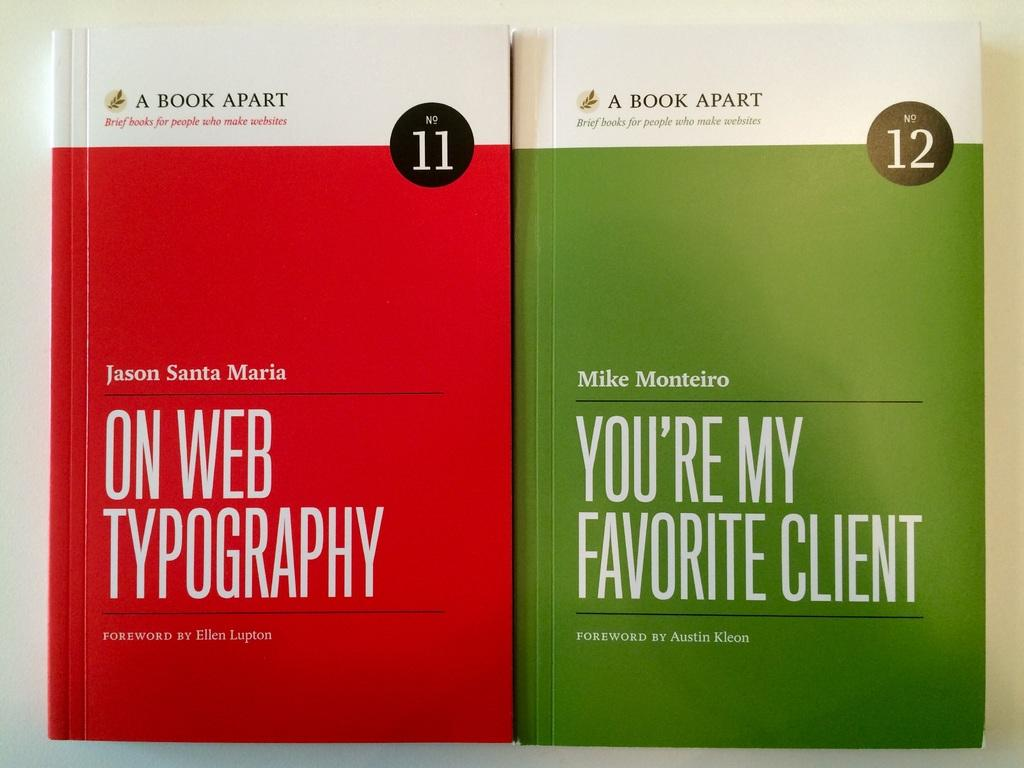<image>
Give a short and clear explanation of the subsequent image. Two books side by side with one titled On Web Typography. 